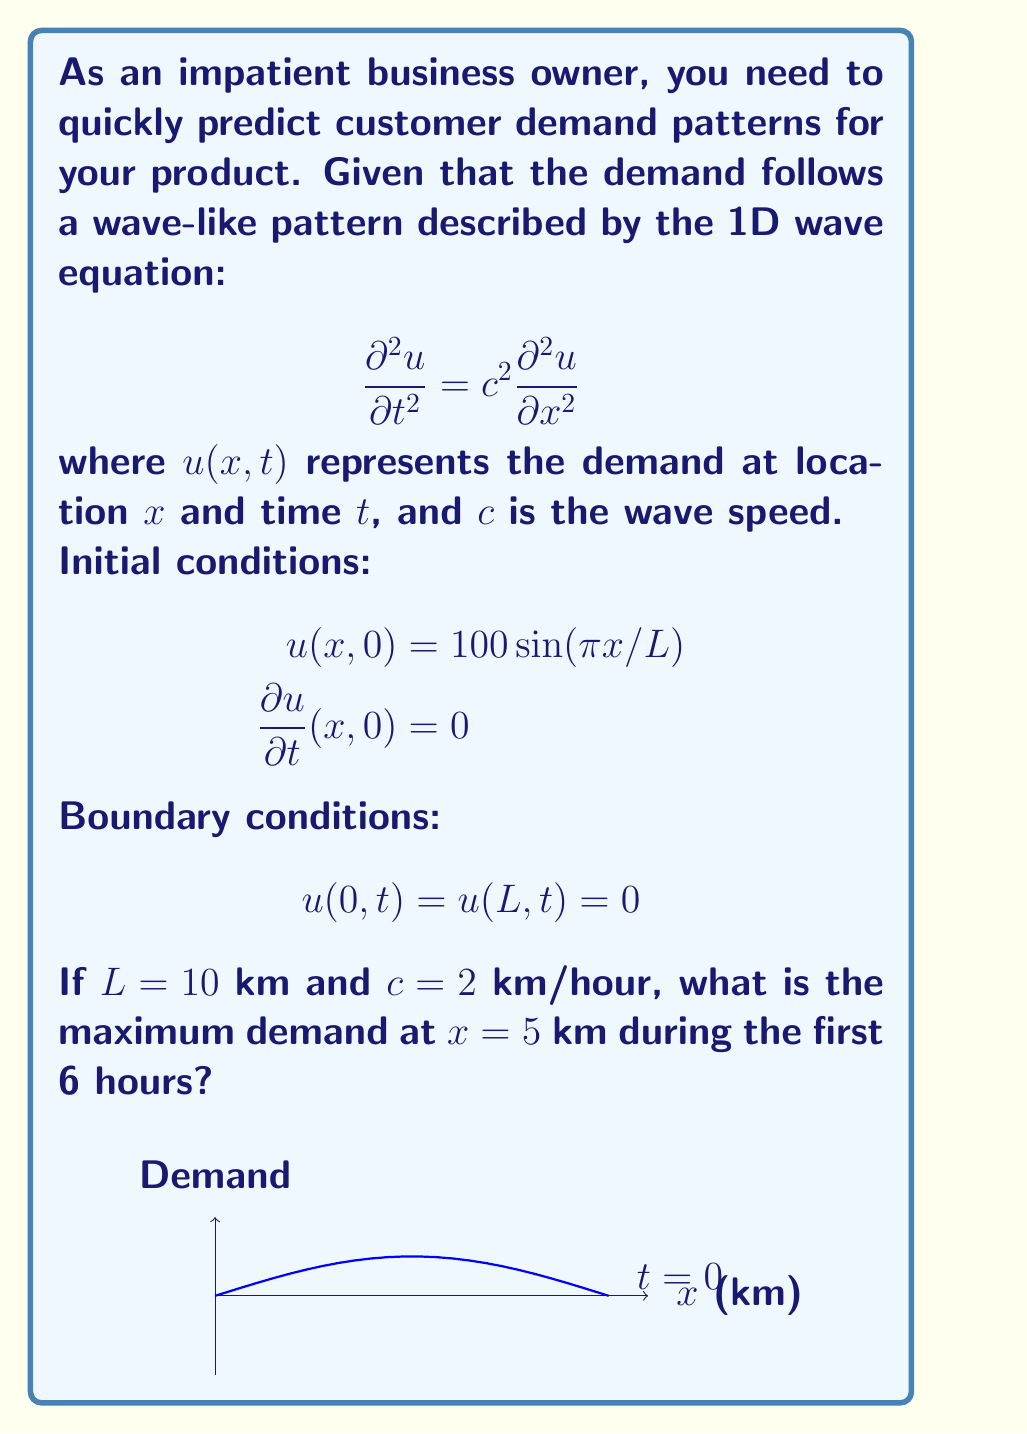Give your solution to this math problem. To solve this problem, we need to use the general solution of the 1D wave equation with the given initial and boundary conditions:

1) The general solution for this problem is:
   $$u(x,t) = \sum_{n=1}^{\infty} A_n \sin(\frac{n\pi x}{L}) \cos(\frac{n\pi c t}{L})$$

2) From the initial condition $u(x,0) = 100 \sin(\pi x/L)$, we can see that only the first term $(n=1)$ is non-zero, and $A_1 = 100$.

3) Therefore, our solution simplifies to:
   $$u(x,t) = 100 \sin(\frac{\pi x}{L}) \cos(\frac{\pi c t}{L})$$

4) At $x = 5$ km (middle of the interval), $\sin(\frac{\pi x}{L}) = \sin(\frac{\pi 5}{10}) = \sin(\frac{\pi}{2}) = 1$

5) So, the demand at $x = 5$ km is:
   $$u(5,t) = 100 \cos(\frac{\pi c t}{L}) = 100 \cos(\frac{\pi 2 t}{10}) = 100 \cos(\frac{\pi t}{5})$$

6) The maximum value of cosine is 1, which occurs when its argument is a multiple of $2\pi$.

7) In the first 6 hours, the maximum will occur at $t = 0$ and $t = 5$ hours (when $\frac{\pi t}{5} = 0$ and $\pi$ respectively).

8) Therefore, the maximum demand at $x = 5$ km during the first 6 hours is 100.
Answer: 100 units 